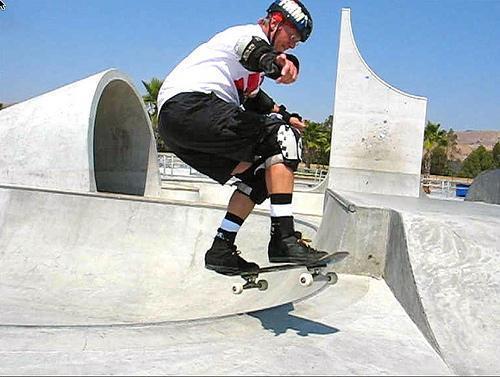How many ties are there?
Give a very brief answer. 0. 